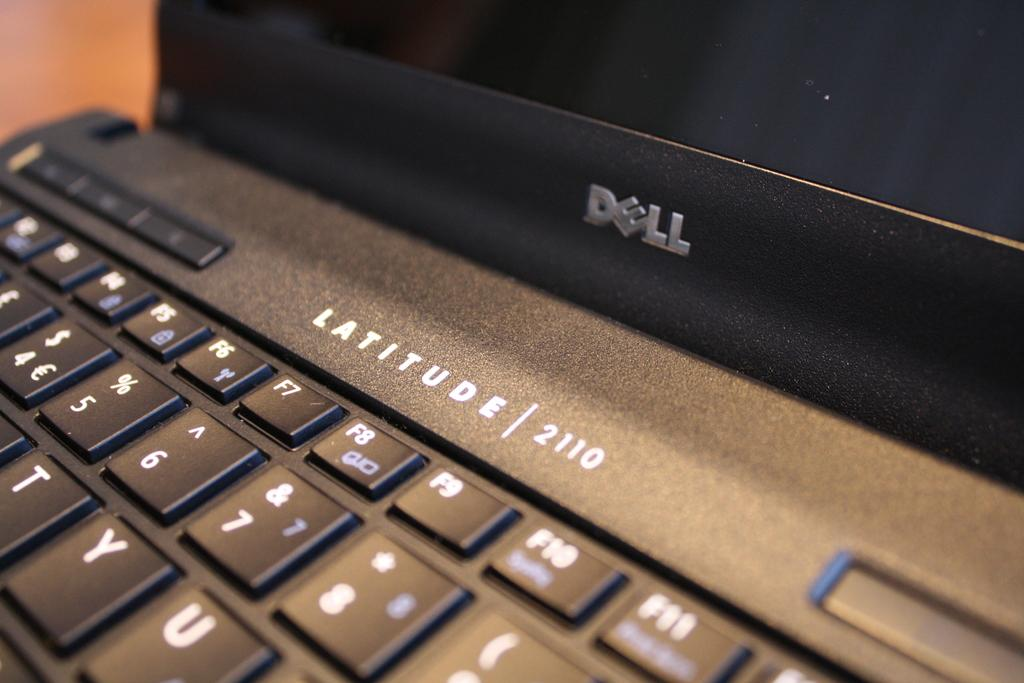<image>
Relay a brief, clear account of the picture shown. The upper portion of a keyboard on a Dell brand computer. 